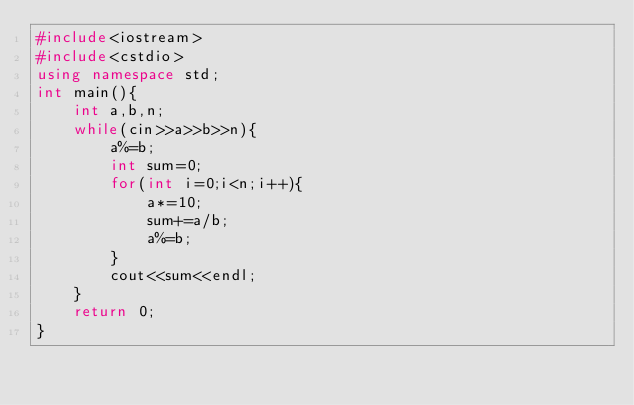<code> <loc_0><loc_0><loc_500><loc_500><_C++_>#include<iostream>
#include<cstdio>
using namespace std;
int main(){
    int a,b,n;
    while(cin>>a>>b>>n){
        a%=b;
        int sum=0;
        for(int i=0;i<n;i++){
            a*=10;
            sum+=a/b;
            a%=b;
        }
        cout<<sum<<endl;
    }
    return 0;
}</code> 